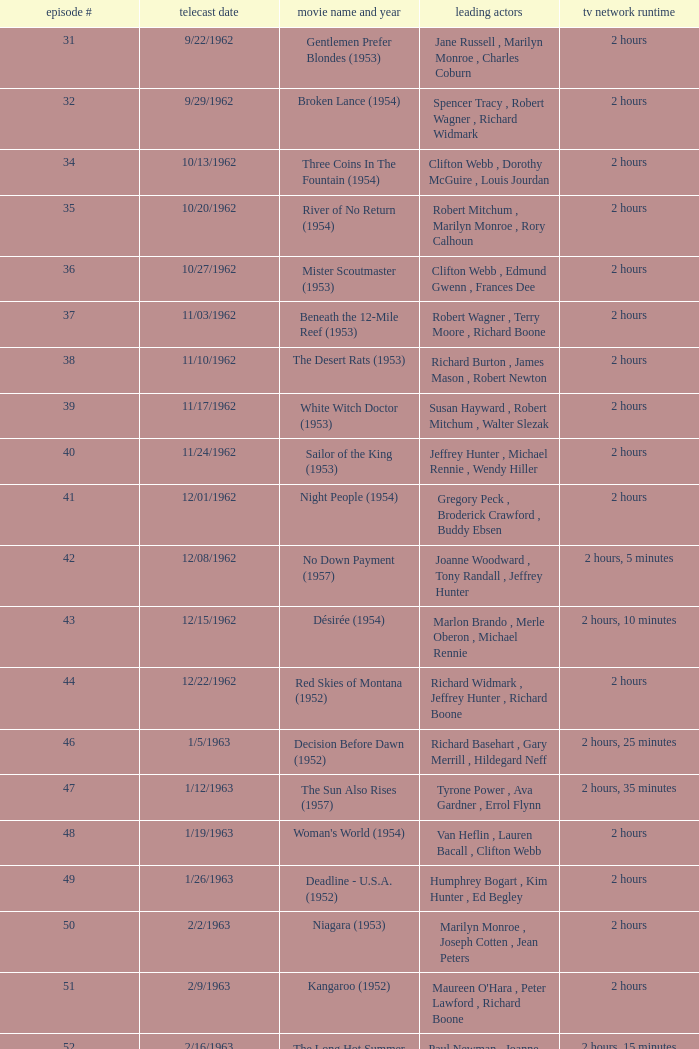What movie did dana wynter , mel ferrer , theodore bikel star in? Fraulein (1958). 